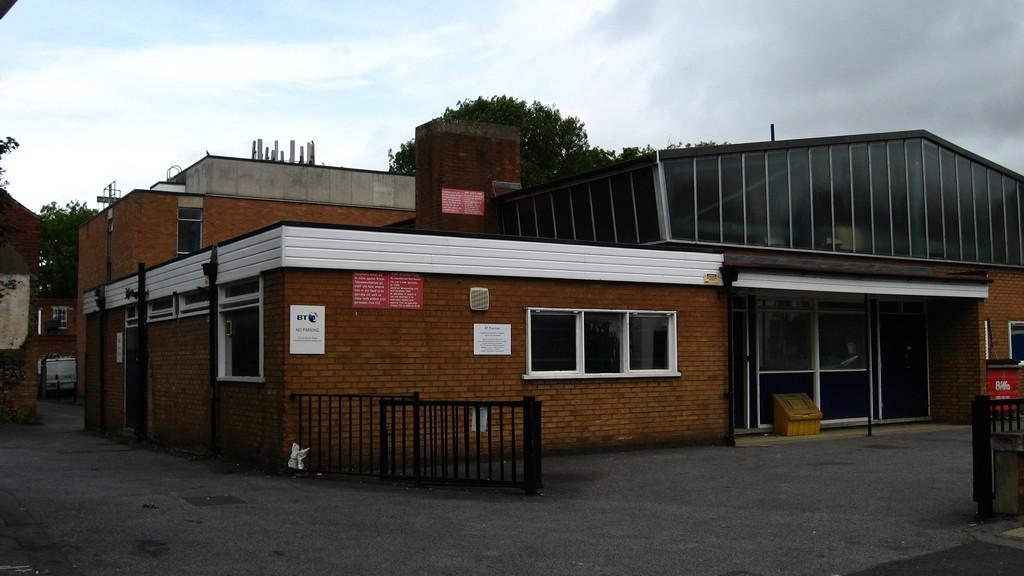Could you give a brief overview of what you see in this image? It is a house, in the middle there are trees. At the top it is the sky. 